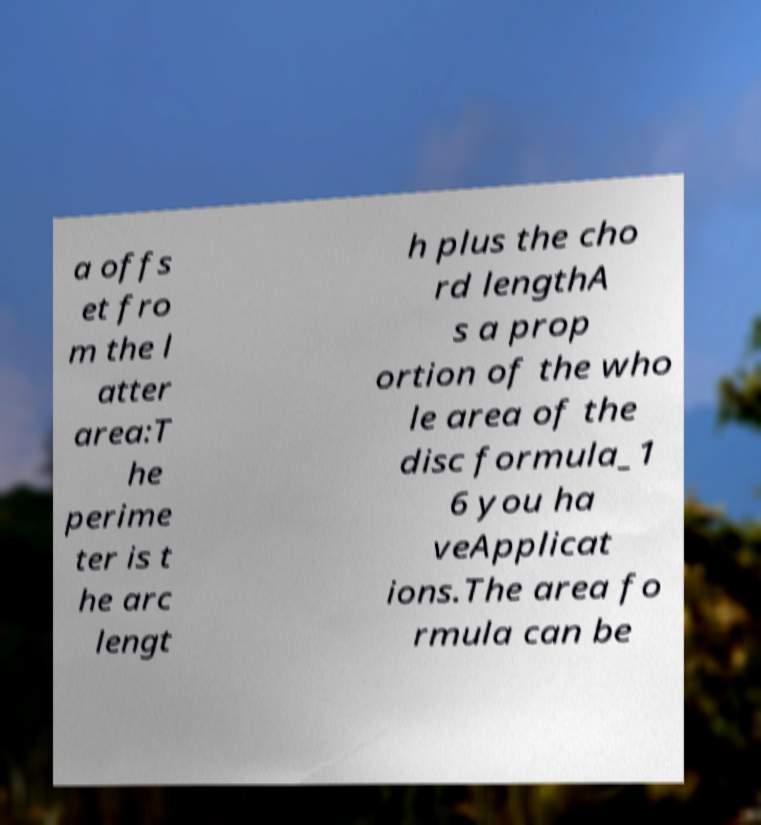Please identify and transcribe the text found in this image. a offs et fro m the l atter area:T he perime ter is t he arc lengt h plus the cho rd lengthA s a prop ortion of the who le area of the disc formula_1 6 you ha veApplicat ions.The area fo rmula can be 